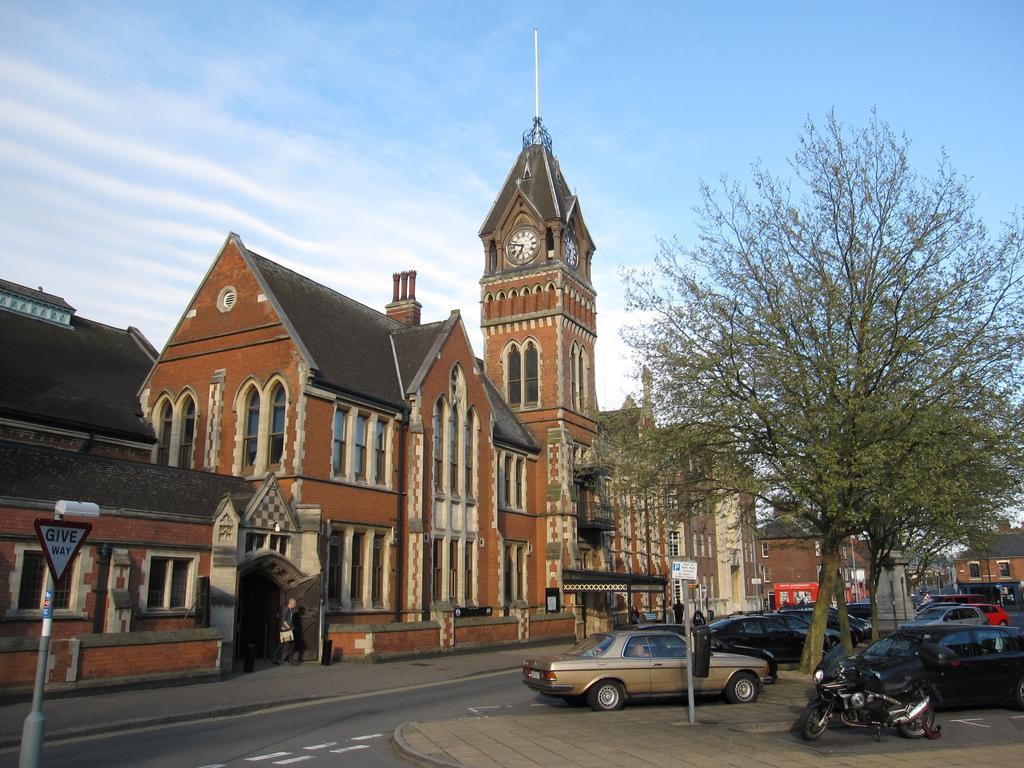In one or two sentences, can you explain what this image depicts? In this image I can see few vehicles, background I can see few buildings in brown and cream color and the clock attached to the building, trees in green color and the sky is in white and blue color. 